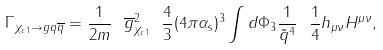Convert formula to latex. <formula><loc_0><loc_0><loc_500><loc_500>\Gamma _ { \chi _ { c 1 } \rightarrow g q { \overline { q } } } = \frac { 1 } { 2 m } \ { \overline { g } } ^ { 2 } _ { \chi _ { c 1 } } \ \frac { 4 } { 3 } ( 4 \pi \alpha _ { s } ) ^ { 3 } \int d \Phi _ { 3 } \frac { 1 } { \tilde { q } ^ { 4 } } \ \frac { 1 } { 4 } h _ { \mu \nu } H ^ { \mu \nu } ,</formula> 